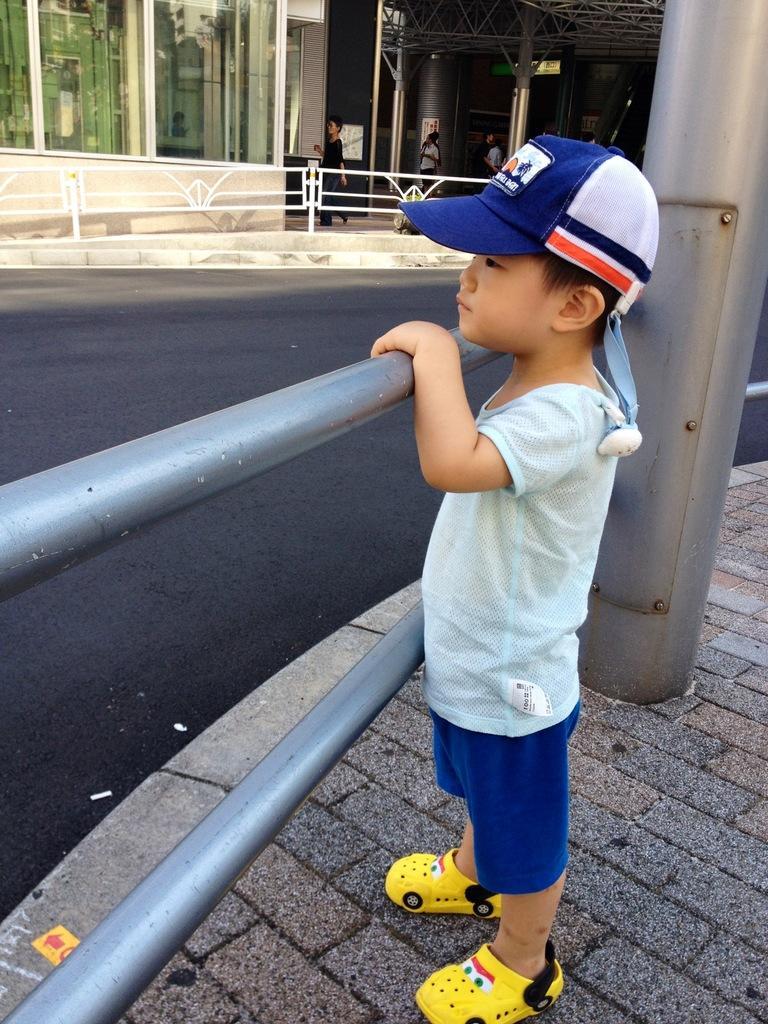Could you give a brief overview of what you see in this image? To the bottom of the image there is a boy with a t-shirt, blue short, yellow footwear and blue and white color cap on his head is standing on the footpath and holding the fencing rods. Beside him there is a pole. In front of the boy there is a road. Behind the road there is a fencing. Behind the fencing there is a building with glass window and few people are standing. And also there are poles.  